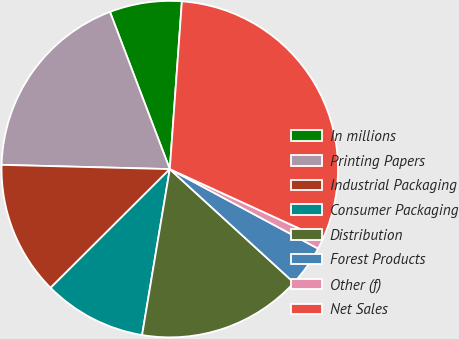Convert chart to OTSL. <chart><loc_0><loc_0><loc_500><loc_500><pie_chart><fcel>In millions<fcel>Printing Papers<fcel>Industrial Packaging<fcel>Consumer Packaging<fcel>Distribution<fcel>Forest Products<fcel>Other (f)<fcel>Net Sales<nl><fcel>6.93%<fcel>18.81%<fcel>12.87%<fcel>9.9%<fcel>15.84%<fcel>3.96%<fcel>0.99%<fcel>30.69%<nl></chart> 